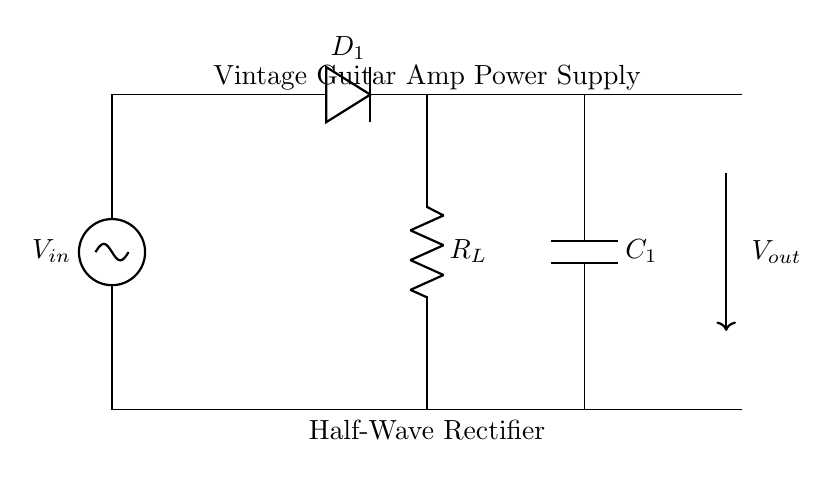what type of rectifier is shown in the diagram? The circuit is labeled as a "Half-Wave Rectifier," indicating that it uses only one half of the AC waveform.
Answer: Half-Wave Rectifier what is the component labeled D1? D1 in the diagram is a diode which allows current to flow in one direction only, thus it is responsible for rectification.
Answer: Diode how many capacitors are present in the circuit? The diagram clearly shows one capacitor labeled C1.
Answer: One what is the function of the resistor R_L? R_L is labeled as the load resistor, which dissipates power from the rectifier circuit, allowing the output voltage to power the connected load.
Answer: Load resistor what voltage does V_out represent? V_out represents the output voltage of the rectifier circuit after rectification and filtering by capacitor C1, which smooths the signal.
Answer: Output voltage what happens to the output voltage during the negative cycle of the AC input? During the negative cycle of the AC input, the diode becomes reverse-biased and blocks current flow, resulting in zero output voltage.
Answer: Zero output voltage how does the capacitor C1 affect the output signal? C1 smooths the output signal by charging during the peak of the input and discharging between cycles, reducing the ripple in the output voltage.
Answer: Reduces ripple 